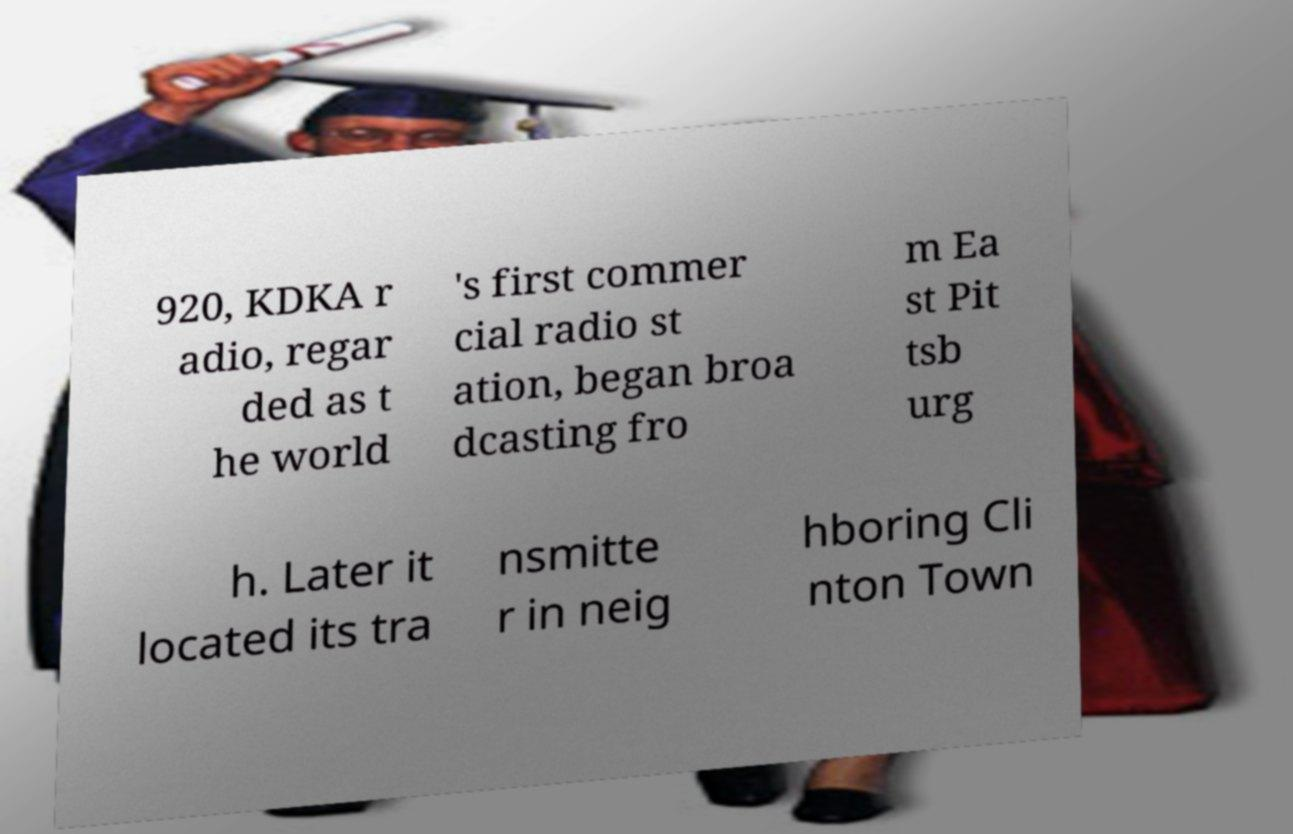There's text embedded in this image that I need extracted. Can you transcribe it verbatim? 920, KDKA r adio, regar ded as t he world 's first commer cial radio st ation, began broa dcasting fro m Ea st Pit tsb urg h. Later it located its tra nsmitte r in neig hboring Cli nton Town 